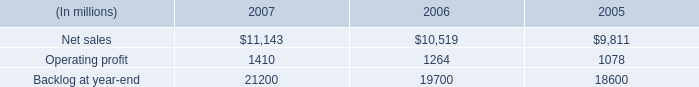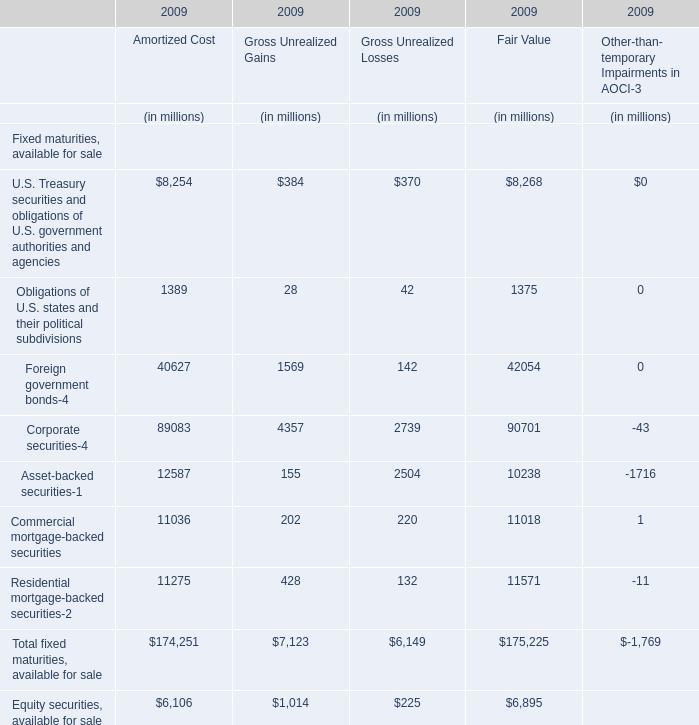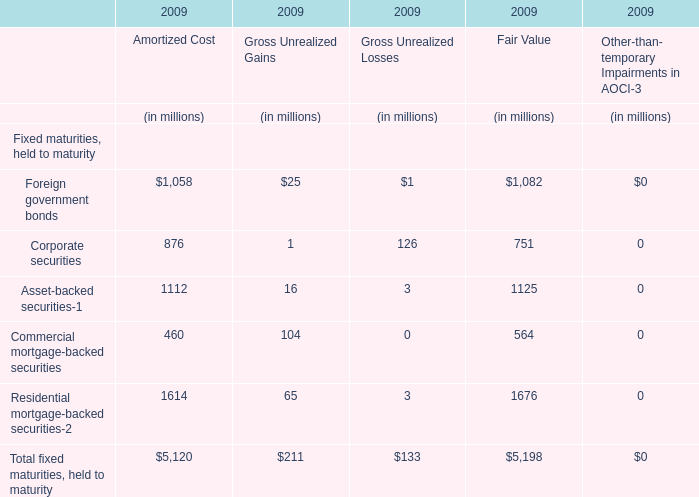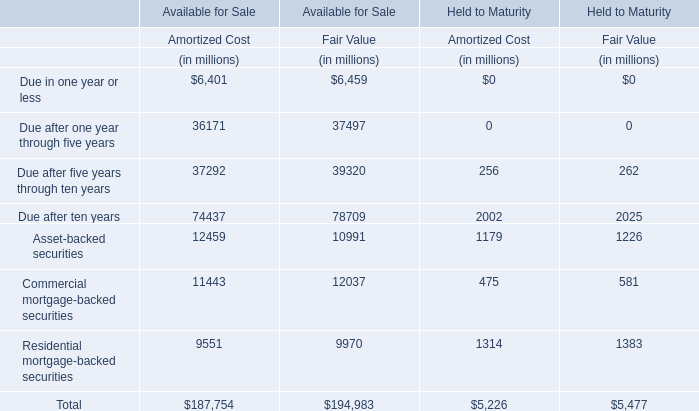What was the total amount of Amortized Cost greater than 30000 for Available for Sale? (in million) 
Computations: ((36171 + 37292) + 74437)
Answer: 147900.0. 